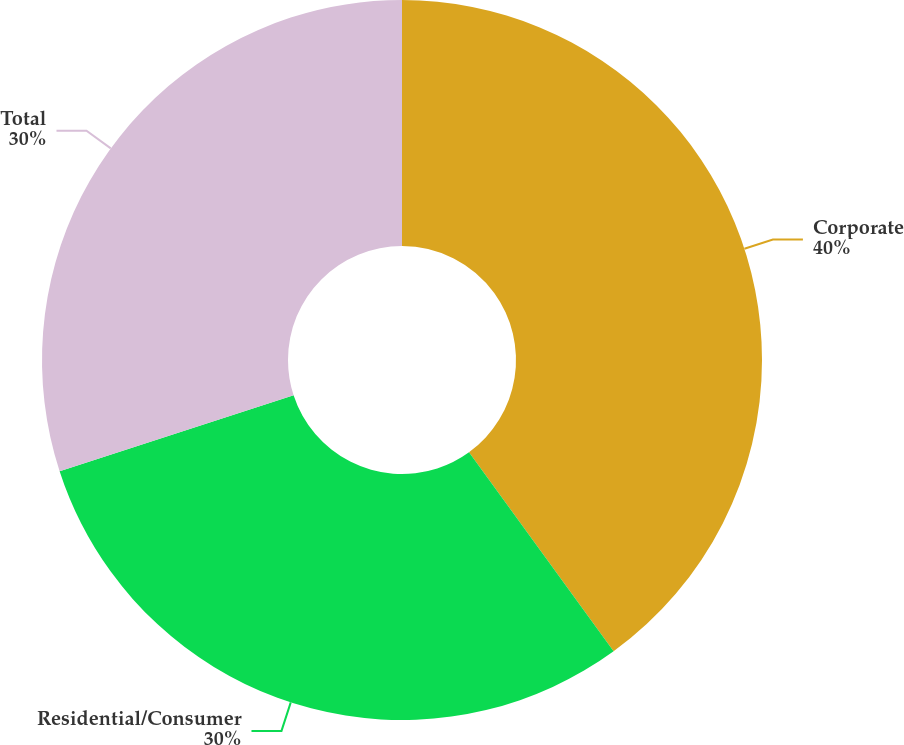Convert chart. <chart><loc_0><loc_0><loc_500><loc_500><pie_chart><fcel>Corporate<fcel>Residential/Consumer<fcel>Total<nl><fcel>40.0%<fcel>30.0%<fcel>30.0%<nl></chart> 